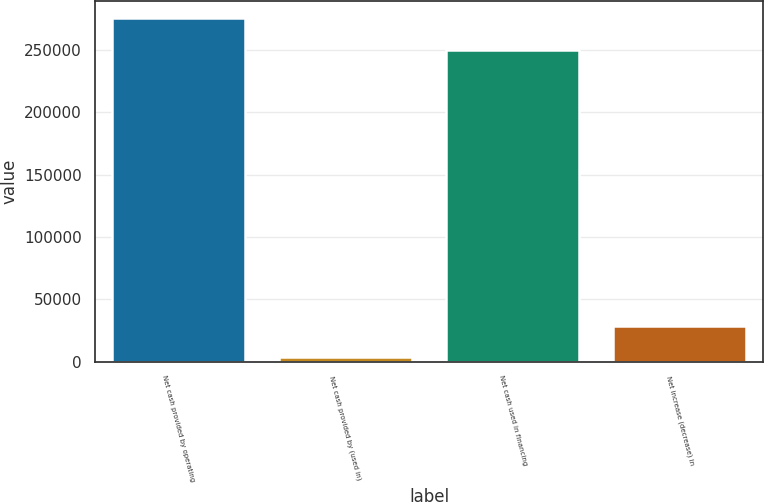<chart> <loc_0><loc_0><loc_500><loc_500><bar_chart><fcel>Net cash provided by operating<fcel>Net cash provided by (used in)<fcel>Net cash used in financing<fcel>Net increase (decrease) in<nl><fcel>275250<fcel>3623<fcel>249891<fcel>28982.2<nl></chart> 